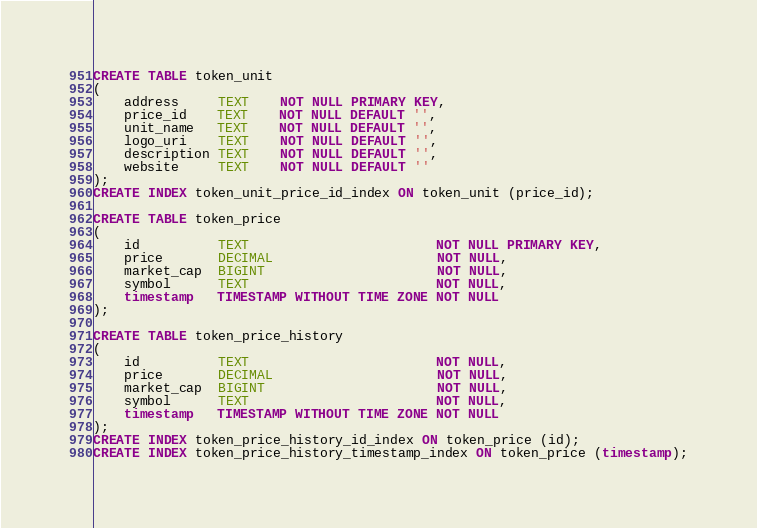<code> <loc_0><loc_0><loc_500><loc_500><_SQL_>CREATE TABLE token_unit
(
    address     TEXT    NOT NULL PRIMARY KEY,
    price_id    TEXT    NOT NULL DEFAULT '',
    unit_name   TEXT    NOT NULL DEFAULT '',
    logo_uri    TEXT    NOT NULL DEFAULT '',
    description TEXT    NOT NULL DEFAULT '',
    website     TEXT    NOT NULL DEFAULT ''
);
CREATE INDEX token_unit_price_id_index ON token_unit (price_id);

CREATE TABLE token_price
(
    id          TEXT                        NOT NULL PRIMARY KEY,
    price       DECIMAL                     NOT NULL,
    market_cap  BIGINT                      NOT NULL,
    symbol      TEXT                        NOT NULL,
    timestamp   TIMESTAMP WITHOUT TIME ZONE NOT NULL
);

CREATE TABLE token_price_history
(
    id          TEXT                        NOT NULL,
    price       DECIMAL                     NOT NULL,
    market_cap  BIGINT                      NOT NULL,
    symbol      TEXT                        NOT NULL,
    timestamp   TIMESTAMP WITHOUT TIME ZONE NOT NULL
);
CREATE INDEX token_price_history_id_index ON token_price (id);
CREATE INDEX token_price_history_timestamp_index ON token_price (timestamp);

</code> 